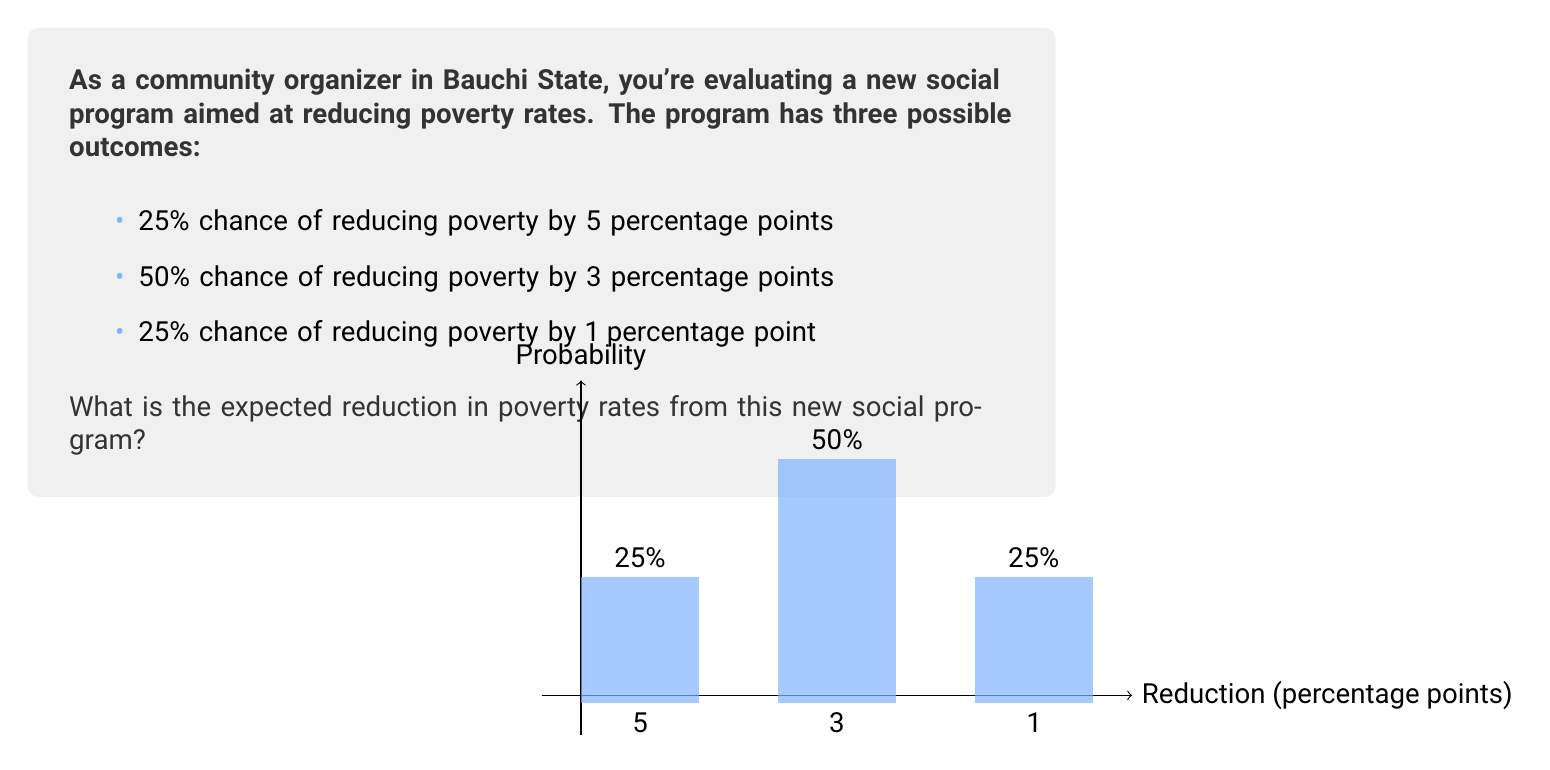Give your solution to this math problem. To solve this problem, we need to calculate the expected value of the poverty rate reduction. The expected value is the sum of each possible outcome multiplied by its probability.

Let's break it down step by step:

1) First, let's define our outcomes and their probabilities:
   - Outcome 1: 5 percentage point reduction, probability = 0.25
   - Outcome 2: 3 percentage point reduction, probability = 0.50
   - Outcome 3: 1 percentage point reduction, probability = 0.25

2) Now, let's calculate the contribution of each outcome to the expected value:
   - Outcome 1: $5 \times 0.25 = 1.25$
   - Outcome 2: $3 \times 0.50 = 1.50$
   - Outcome 3: $1 \times 0.25 = 0.25$

3) The expected value is the sum of these contributions:

   $$E = (5 \times 0.25) + (3 \times 0.50) + (1 \times 0.25)$$
   $$E = 1.25 + 1.50 + 0.25 = 3$$

Therefore, the expected reduction in poverty rates from this new social program is 3 percentage points.
Answer: 3 percentage points 